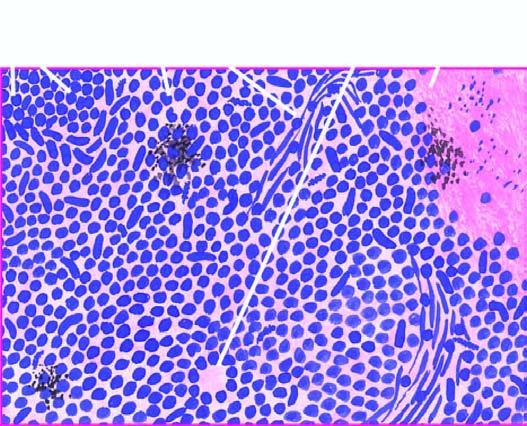re the atypical dysplastic squamous cells small, uniform, lymphocyte-like with scanty cytoplasm?
Answer the question using a single word or phrase. No 